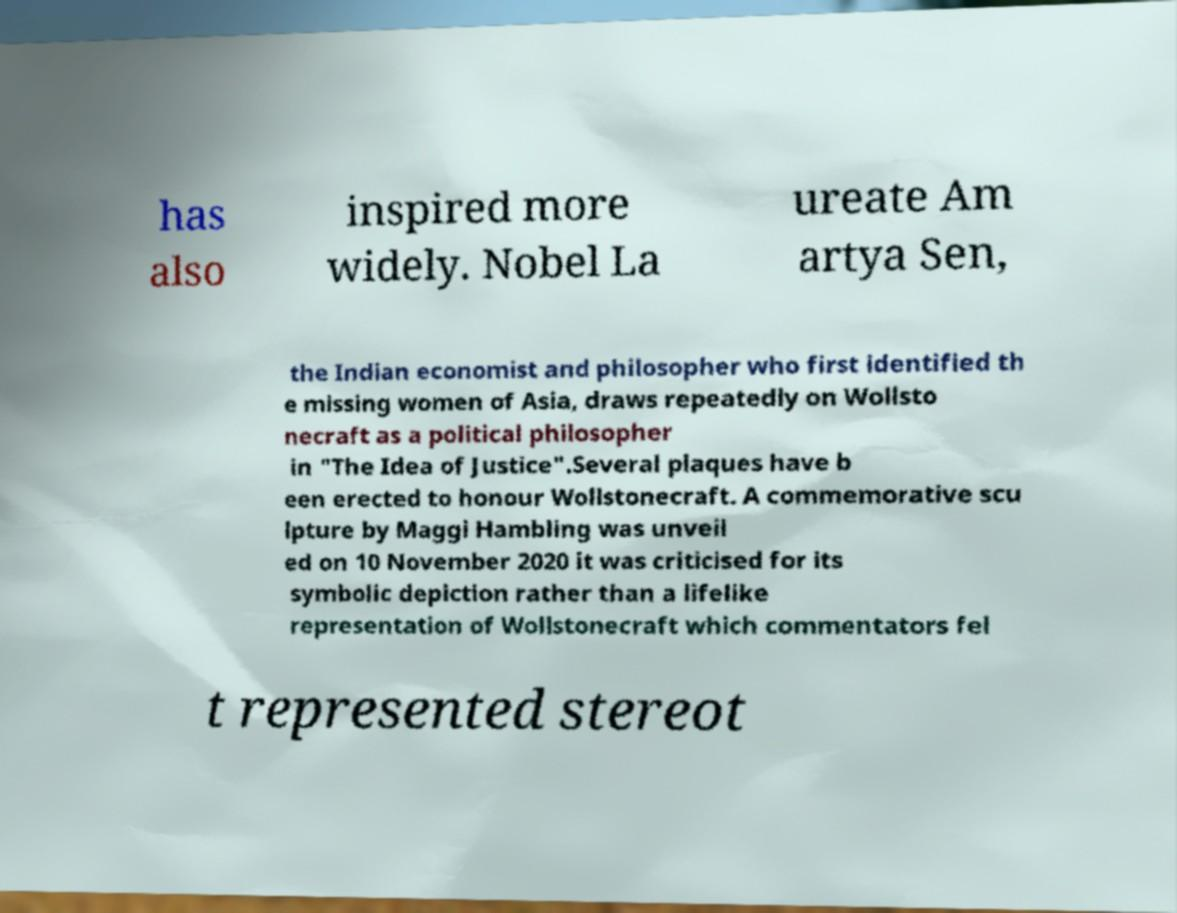Can you read and provide the text displayed in the image?This photo seems to have some interesting text. Can you extract and type it out for me? has also inspired more widely. Nobel La ureate Am artya Sen, the Indian economist and philosopher who first identified th e missing women of Asia, draws repeatedly on Wollsto necraft as a political philosopher in "The Idea of Justice".Several plaques have b een erected to honour Wollstonecraft. A commemorative scu lpture by Maggi Hambling was unveil ed on 10 November 2020 it was criticised for its symbolic depiction rather than a lifelike representation of Wollstonecraft which commentators fel t represented stereot 